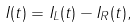Convert formula to latex. <formula><loc_0><loc_0><loc_500><loc_500>I ( t ) = I _ { L } ( t ) - I _ { R } ( t ) ,</formula> 